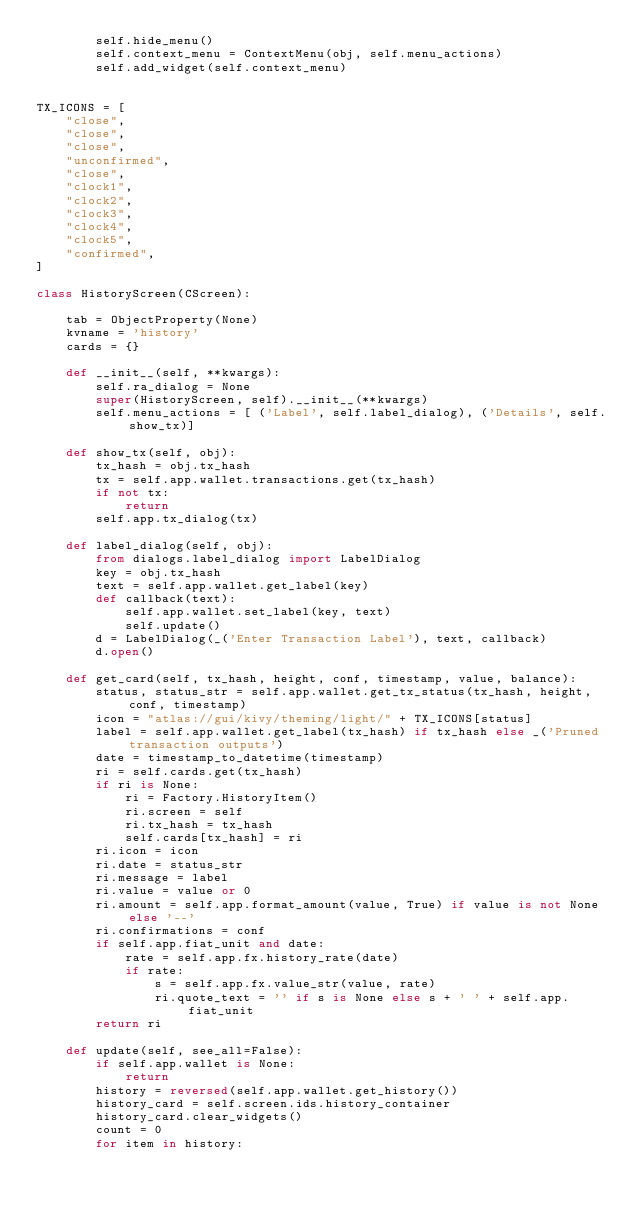<code> <loc_0><loc_0><loc_500><loc_500><_Python_>        self.hide_menu()
        self.context_menu = ContextMenu(obj, self.menu_actions)
        self.add_widget(self.context_menu)


TX_ICONS = [
    "close",
    "close",
    "close",
    "unconfirmed",
    "close",
    "clock1",
    "clock2",
    "clock3",
    "clock4",
    "clock5",
    "confirmed",
]

class HistoryScreen(CScreen):

    tab = ObjectProperty(None)
    kvname = 'history'
    cards = {}

    def __init__(self, **kwargs):
        self.ra_dialog = None
        super(HistoryScreen, self).__init__(**kwargs)
        self.menu_actions = [ ('Label', self.label_dialog), ('Details', self.show_tx)]

    def show_tx(self, obj):
        tx_hash = obj.tx_hash
        tx = self.app.wallet.transactions.get(tx_hash)
        if not tx:
            return
        self.app.tx_dialog(tx)

    def label_dialog(self, obj):
        from dialogs.label_dialog import LabelDialog
        key = obj.tx_hash
        text = self.app.wallet.get_label(key)
        def callback(text):
            self.app.wallet.set_label(key, text)
            self.update()
        d = LabelDialog(_('Enter Transaction Label'), text, callback)
        d.open()

    def get_card(self, tx_hash, height, conf, timestamp, value, balance):
        status, status_str = self.app.wallet.get_tx_status(tx_hash, height, conf, timestamp)
        icon = "atlas://gui/kivy/theming/light/" + TX_ICONS[status]
        label = self.app.wallet.get_label(tx_hash) if tx_hash else _('Pruned transaction outputs')
        date = timestamp_to_datetime(timestamp)
        ri = self.cards.get(tx_hash)
        if ri is None:
            ri = Factory.HistoryItem()
            ri.screen = self
            ri.tx_hash = tx_hash
            self.cards[tx_hash] = ri
        ri.icon = icon
        ri.date = status_str
        ri.message = label
        ri.value = value or 0
        ri.amount = self.app.format_amount(value, True) if value is not None else '--'
        ri.confirmations = conf
        if self.app.fiat_unit and date:
            rate = self.app.fx.history_rate(date)
            if rate:
                s = self.app.fx.value_str(value, rate)
                ri.quote_text = '' if s is None else s + ' ' + self.app.fiat_unit
        return ri

    def update(self, see_all=False):
        if self.app.wallet is None:
            return
        history = reversed(self.app.wallet.get_history())
        history_card = self.screen.ids.history_container
        history_card.clear_widgets()
        count = 0
        for item in history:</code> 